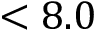Convert formula to latex. <formula><loc_0><loc_0><loc_500><loc_500>< 8 . 0</formula> 